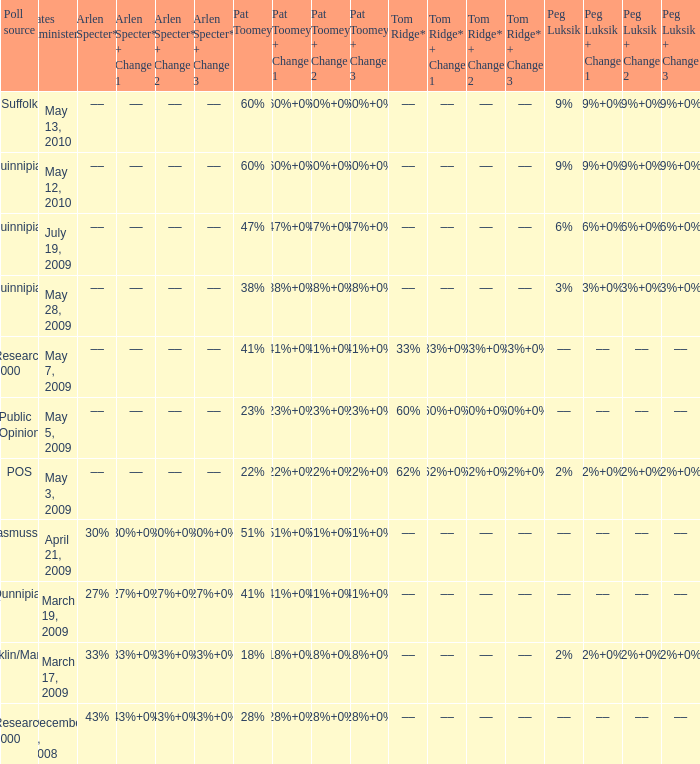Which Poll source has a Peg Luksik of 9%, and Dates administered of may 12, 2010? Quinnipiac. 